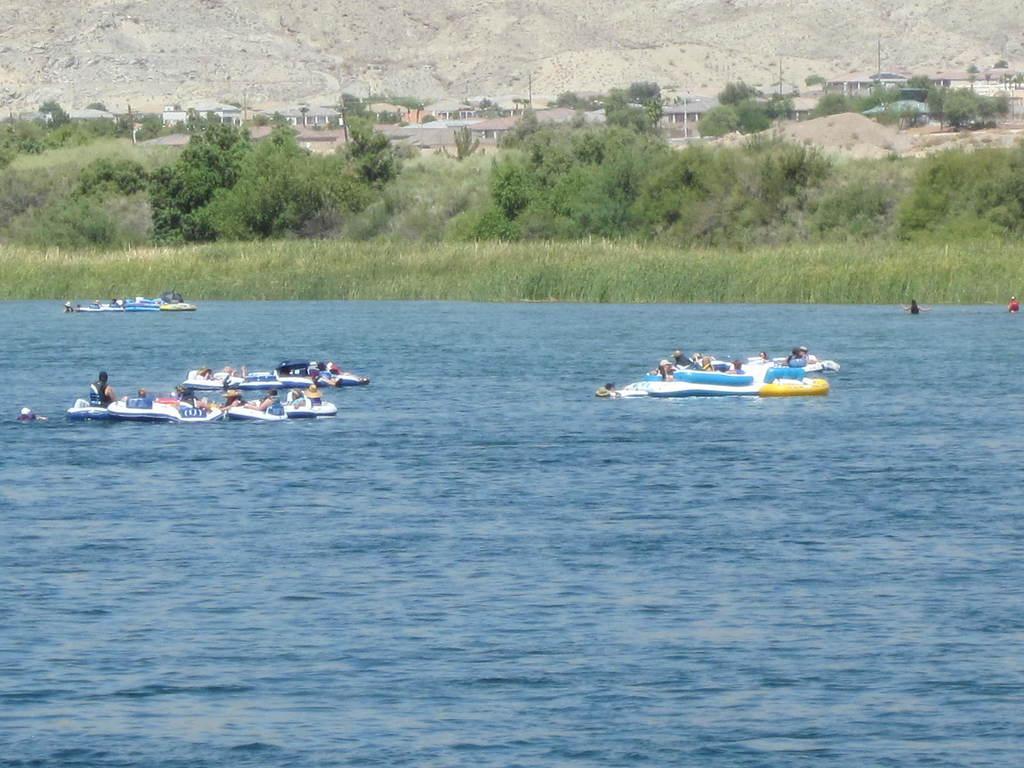Can you describe this image briefly? In this image in the center there are persons surfing on a boat and in the background there are plants, buildings and in the front there is water and on the right side in the background there are persons in the water. 